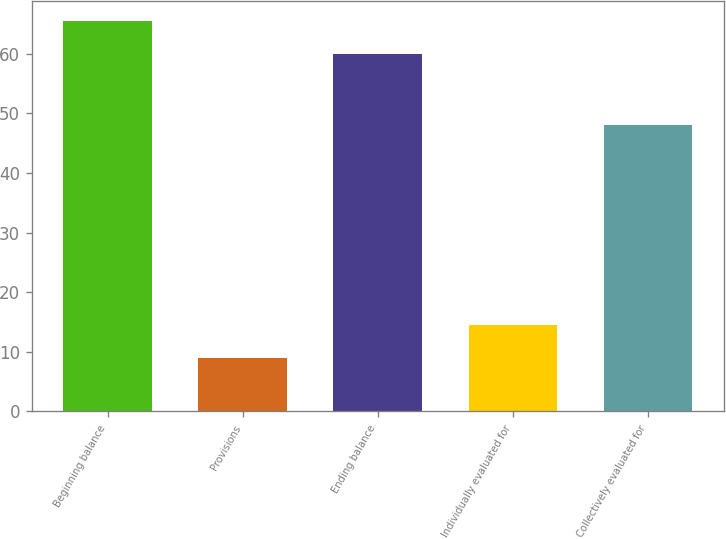<chart> <loc_0><loc_0><loc_500><loc_500><bar_chart><fcel>Beginning balance<fcel>Provisions<fcel>Ending balance<fcel>Individually evaluated for<fcel>Collectively evaluated for<nl><fcel>65.5<fcel>9<fcel>60<fcel>14.5<fcel>48<nl></chart> 